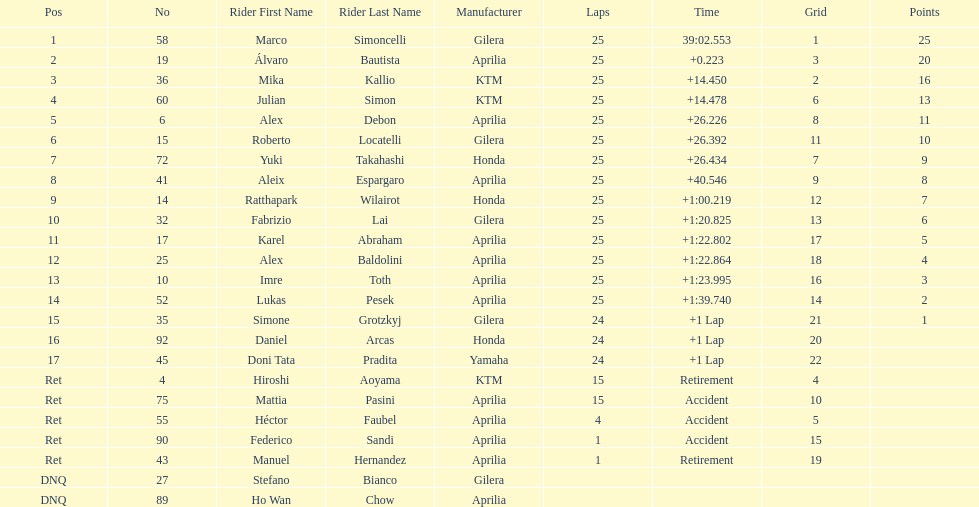The country with the most riders was Italy. 